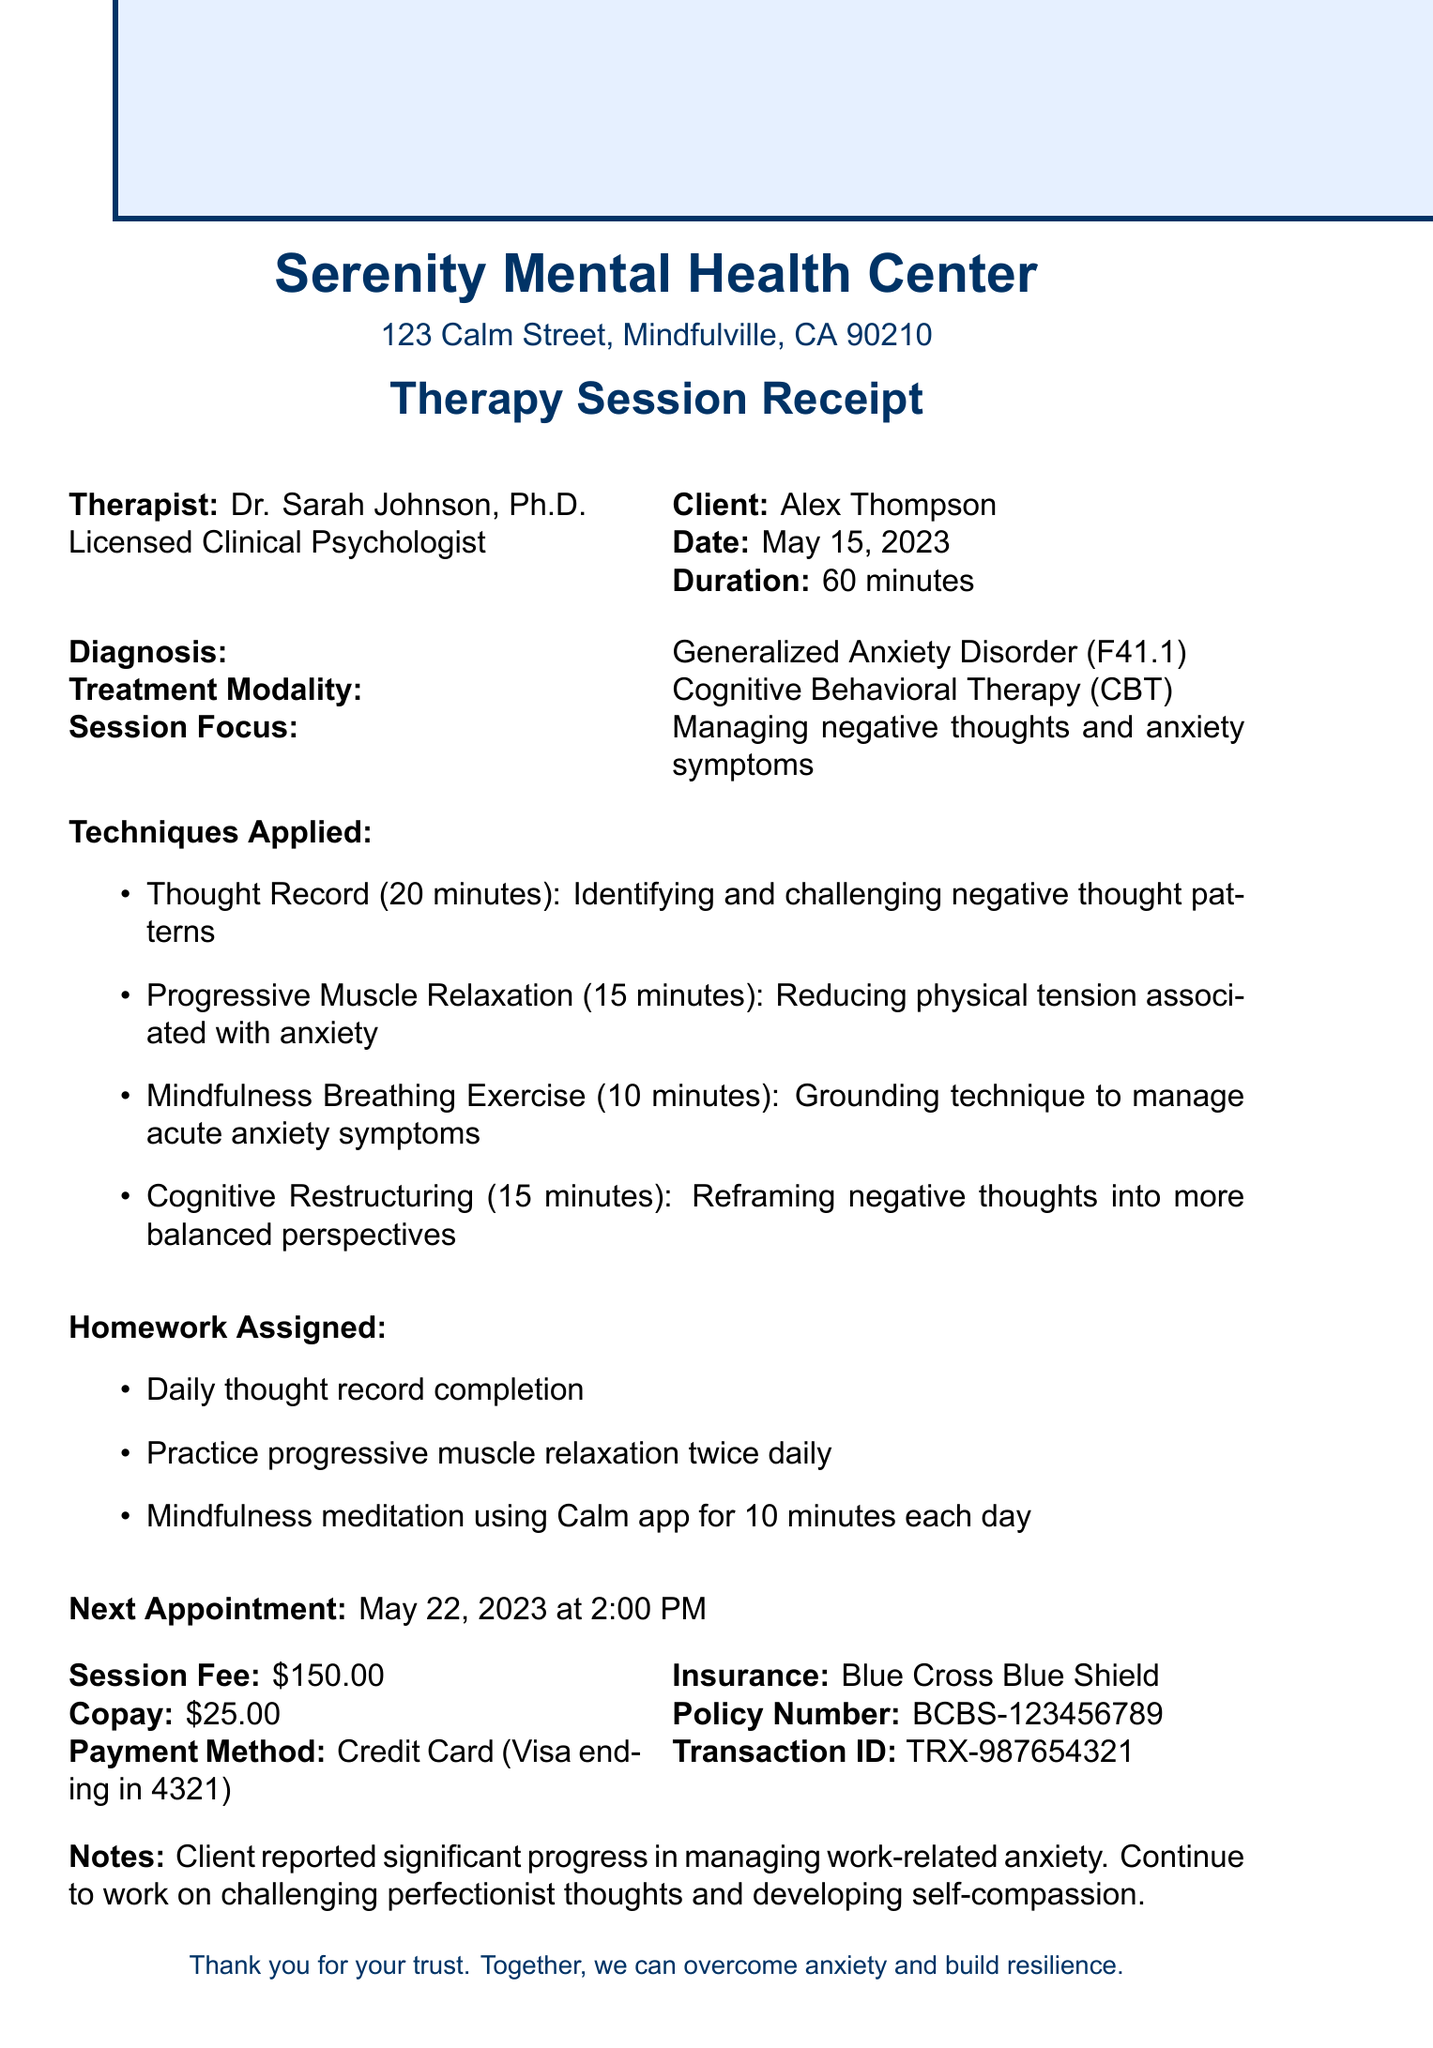What is the therapist's name? The therapist's name is mentioned at the top of the receipt.
Answer: Dr. Sarah Johnson What is the session date? The session date is listed under the client details section.
Answer: May 15, 2023 What is the session fee? The session fee is specified in the financial details section.
Answer: $150.00 How long was the session? The duration of the session is noted alongside the date.
Answer: 60 minutes What diagnosis does the client have? The client's diagnosis is indicated in the treatment details.
Answer: Generalized Anxiety Disorder (F41.1) What technique was used for reducing physical tension? Techniques are listed with their descriptions; one specifically addresses physical tension.
Answer: Progressive Muscle Relaxation What homework was assigned? The homework assigned is mentioned in a specific section on homework.
Answer: Daily thought record completion When is the next appointment scheduled? The next appointment date and time are explicitly mentioned at the end of the document.
Answer: May 22, 2023 at 2:00 PM What insurance provider is listed? The insurance provider is included in the payment details section.
Answer: Blue Cross Blue Shield What was noted about the client's progress? The notes section provides insight into the client's progress during therapy.
Answer: Significant progress in managing work-related anxiety 